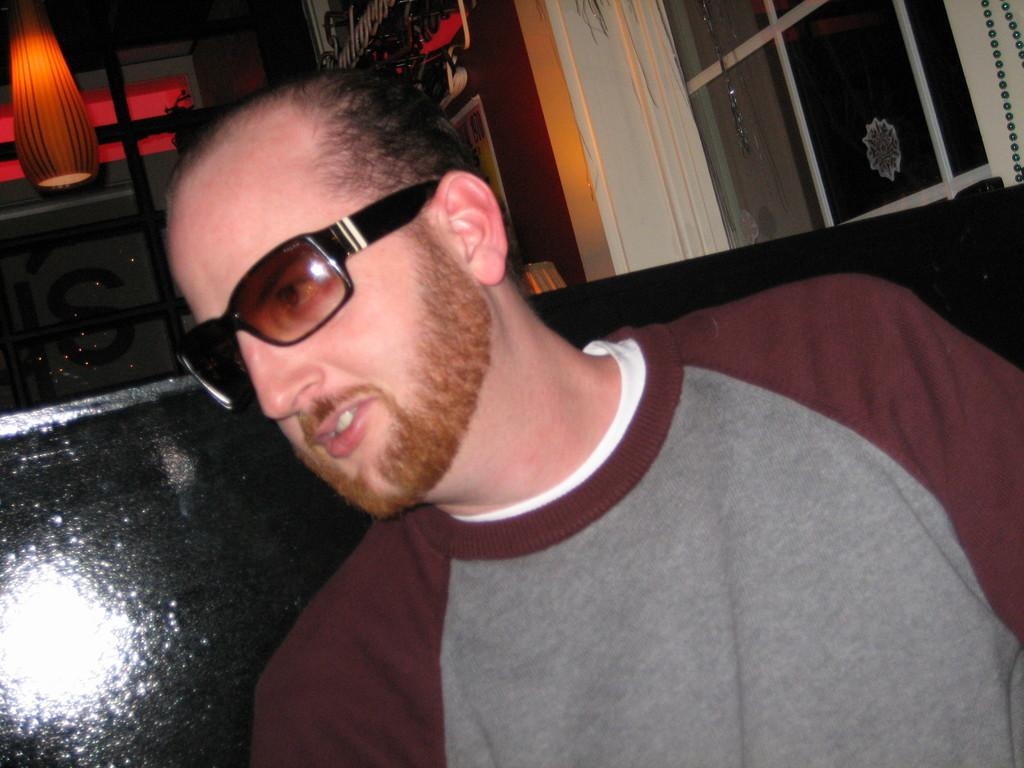Who or what is present in the image? There is a person in the image. Can you describe the person's appearance? The person is wearing spectacles. What else can be seen in the image? There is a lamp in the image. What type of pot is the police officer using to catch the kitty in the image? There is no police officer, pot, or kitty present in the image. 